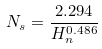<formula> <loc_0><loc_0><loc_500><loc_500>N _ { s } = \frac { 2 . 2 9 4 } { H _ { n } ^ { 0 . 4 8 6 } }</formula> 